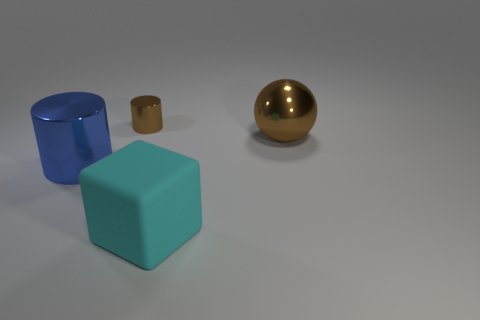Subtract all blue cylinders. How many cylinders are left? 1 Add 2 purple blocks. How many objects exist? 6 Subtract 1 cylinders. How many cylinders are left? 1 Subtract all cyan cylinders. How many purple blocks are left? 0 Add 4 big metallic cylinders. How many big metallic cylinders exist? 5 Subtract 0 cyan cylinders. How many objects are left? 4 Subtract all blocks. How many objects are left? 3 Subtract all red cylinders. Subtract all gray spheres. How many cylinders are left? 2 Subtract all large purple spheres. Subtract all big brown metallic balls. How many objects are left? 3 Add 1 brown cylinders. How many brown cylinders are left? 2 